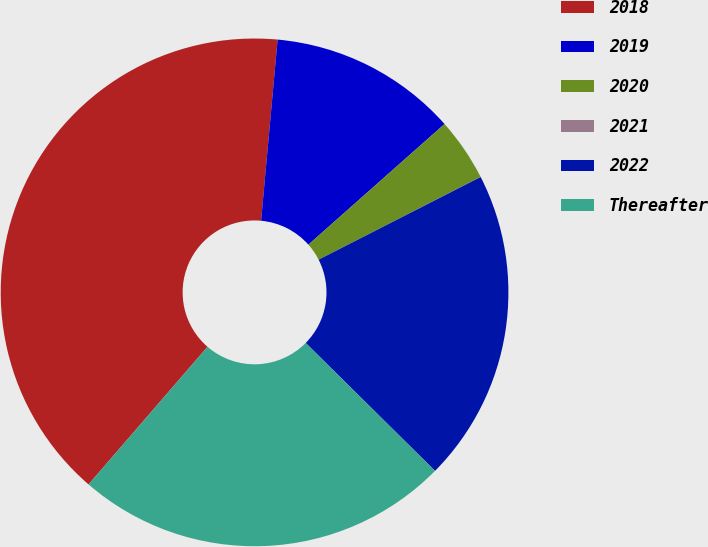<chart> <loc_0><loc_0><loc_500><loc_500><pie_chart><fcel>2018<fcel>2019<fcel>2020<fcel>2021<fcel>2022<fcel>Thereafter<nl><fcel>40.1%<fcel>12.01%<fcel>4.02%<fcel>0.01%<fcel>19.92%<fcel>23.93%<nl></chart> 